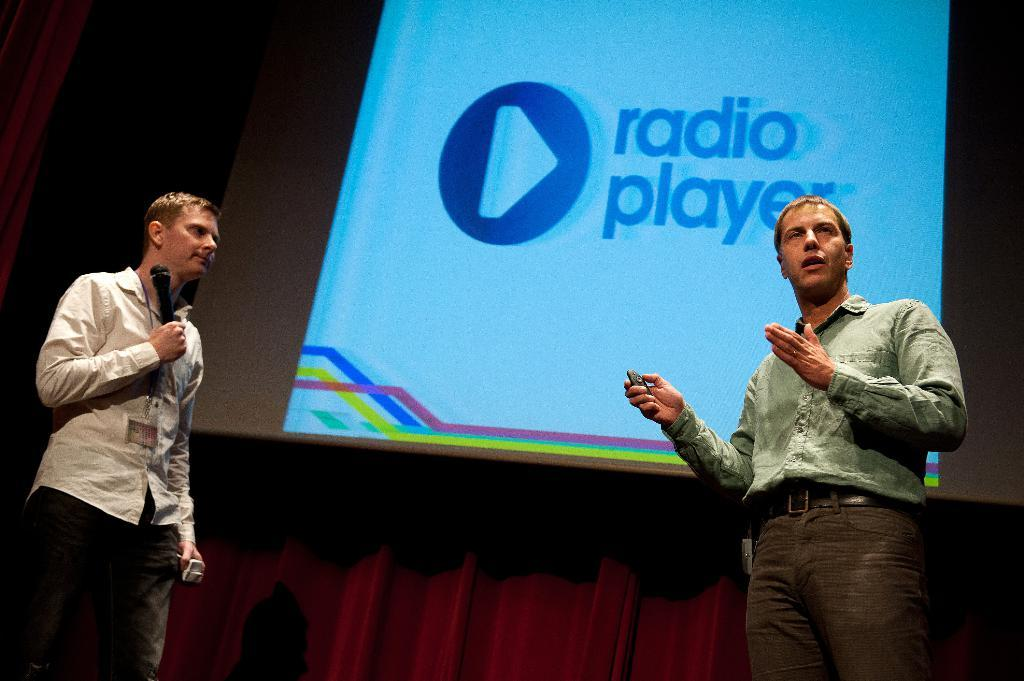How many people are in the image? There are two men in the image. What is one of the men holding? One of the men is holding a microphone. What is the other man holding? The other man is holding an unspecified object in his hand. What can be seen in the background of the image? There is a screen visible in the background of the image. What type of badge is the man wearing on his shirt in the image? There is no badge visible on either man's shirt in the image. What industry does the man with the microphone work in? The image does not provide information about the man's industry or occupation. 